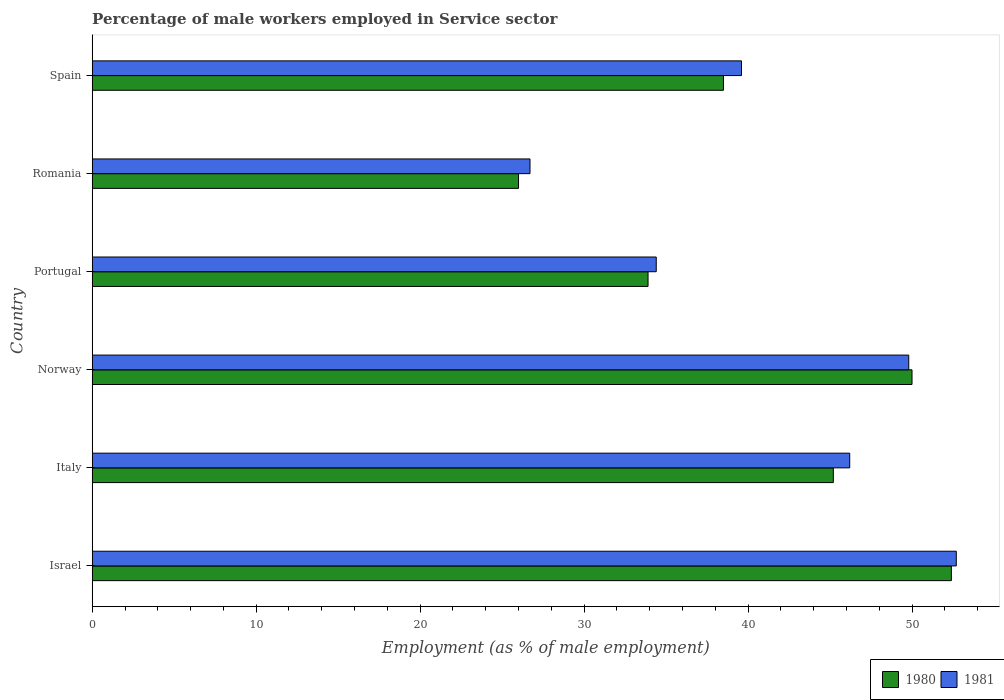How many different coloured bars are there?
Your answer should be very brief. 2. How many groups of bars are there?
Keep it short and to the point. 6. How many bars are there on the 4th tick from the bottom?
Make the answer very short. 2. In how many cases, is the number of bars for a given country not equal to the number of legend labels?
Ensure brevity in your answer.  0. What is the percentage of male workers employed in Service sector in 1980 in Norway?
Your answer should be very brief. 50. Across all countries, what is the maximum percentage of male workers employed in Service sector in 1980?
Provide a short and direct response. 52.4. In which country was the percentage of male workers employed in Service sector in 1980 minimum?
Your answer should be very brief. Romania. What is the total percentage of male workers employed in Service sector in 1981 in the graph?
Offer a terse response. 249.4. What is the difference between the percentage of male workers employed in Service sector in 1980 in Italy and the percentage of male workers employed in Service sector in 1981 in Norway?
Ensure brevity in your answer.  -4.6. What is the average percentage of male workers employed in Service sector in 1980 per country?
Offer a terse response. 41. What is the difference between the percentage of male workers employed in Service sector in 1981 and percentage of male workers employed in Service sector in 1980 in Italy?
Your response must be concise. 1. What is the ratio of the percentage of male workers employed in Service sector in 1981 in Israel to that in Norway?
Provide a short and direct response. 1.06. Is the difference between the percentage of male workers employed in Service sector in 1981 in Italy and Spain greater than the difference between the percentage of male workers employed in Service sector in 1980 in Italy and Spain?
Offer a very short reply. No. What is the difference between the highest and the second highest percentage of male workers employed in Service sector in 1981?
Your answer should be compact. 2.9. What is the difference between the highest and the lowest percentage of male workers employed in Service sector in 1980?
Make the answer very short. 26.4. In how many countries, is the percentage of male workers employed in Service sector in 1981 greater than the average percentage of male workers employed in Service sector in 1981 taken over all countries?
Provide a short and direct response. 3. What does the 2nd bar from the top in Spain represents?
Your answer should be compact. 1980. What does the 2nd bar from the bottom in Spain represents?
Your answer should be very brief. 1981. How many bars are there?
Ensure brevity in your answer.  12. What is the difference between two consecutive major ticks on the X-axis?
Provide a short and direct response. 10. Does the graph contain grids?
Make the answer very short. No. Where does the legend appear in the graph?
Give a very brief answer. Bottom right. How many legend labels are there?
Your answer should be very brief. 2. What is the title of the graph?
Your answer should be compact. Percentage of male workers employed in Service sector. What is the label or title of the X-axis?
Your response must be concise. Employment (as % of male employment). What is the label or title of the Y-axis?
Keep it short and to the point. Country. What is the Employment (as % of male employment) of 1980 in Israel?
Your response must be concise. 52.4. What is the Employment (as % of male employment) of 1981 in Israel?
Provide a short and direct response. 52.7. What is the Employment (as % of male employment) of 1980 in Italy?
Offer a terse response. 45.2. What is the Employment (as % of male employment) of 1981 in Italy?
Your answer should be compact. 46.2. What is the Employment (as % of male employment) in 1980 in Norway?
Your answer should be very brief. 50. What is the Employment (as % of male employment) of 1981 in Norway?
Give a very brief answer. 49.8. What is the Employment (as % of male employment) of 1980 in Portugal?
Your answer should be very brief. 33.9. What is the Employment (as % of male employment) in 1981 in Portugal?
Provide a short and direct response. 34.4. What is the Employment (as % of male employment) in 1980 in Romania?
Give a very brief answer. 26. What is the Employment (as % of male employment) of 1981 in Romania?
Provide a succinct answer. 26.7. What is the Employment (as % of male employment) in 1980 in Spain?
Your answer should be compact. 38.5. What is the Employment (as % of male employment) of 1981 in Spain?
Provide a short and direct response. 39.6. Across all countries, what is the maximum Employment (as % of male employment) of 1980?
Offer a terse response. 52.4. Across all countries, what is the maximum Employment (as % of male employment) in 1981?
Give a very brief answer. 52.7. Across all countries, what is the minimum Employment (as % of male employment) of 1981?
Offer a very short reply. 26.7. What is the total Employment (as % of male employment) of 1980 in the graph?
Your response must be concise. 246. What is the total Employment (as % of male employment) in 1981 in the graph?
Offer a very short reply. 249.4. What is the difference between the Employment (as % of male employment) in 1980 in Israel and that in Italy?
Offer a terse response. 7.2. What is the difference between the Employment (as % of male employment) of 1981 in Israel and that in Italy?
Offer a terse response. 6.5. What is the difference between the Employment (as % of male employment) in 1980 in Israel and that in Norway?
Provide a short and direct response. 2.4. What is the difference between the Employment (as % of male employment) of 1980 in Israel and that in Portugal?
Offer a terse response. 18.5. What is the difference between the Employment (as % of male employment) in 1980 in Israel and that in Romania?
Make the answer very short. 26.4. What is the difference between the Employment (as % of male employment) in 1980 in Israel and that in Spain?
Give a very brief answer. 13.9. What is the difference between the Employment (as % of male employment) in 1980 in Italy and that in Portugal?
Your answer should be compact. 11.3. What is the difference between the Employment (as % of male employment) in 1981 in Italy and that in Portugal?
Provide a succinct answer. 11.8. What is the difference between the Employment (as % of male employment) in 1981 in Italy and that in Romania?
Offer a terse response. 19.5. What is the difference between the Employment (as % of male employment) of 1980 in Italy and that in Spain?
Provide a short and direct response. 6.7. What is the difference between the Employment (as % of male employment) in 1981 in Norway and that in Portugal?
Offer a very short reply. 15.4. What is the difference between the Employment (as % of male employment) of 1980 in Norway and that in Romania?
Make the answer very short. 24. What is the difference between the Employment (as % of male employment) of 1981 in Norway and that in Romania?
Ensure brevity in your answer.  23.1. What is the difference between the Employment (as % of male employment) of 1981 in Norway and that in Spain?
Offer a very short reply. 10.2. What is the difference between the Employment (as % of male employment) of 1980 in Portugal and that in Romania?
Your answer should be very brief. 7.9. What is the difference between the Employment (as % of male employment) of 1980 in Portugal and that in Spain?
Your answer should be compact. -4.6. What is the difference between the Employment (as % of male employment) in 1980 in Israel and the Employment (as % of male employment) in 1981 in Norway?
Offer a terse response. 2.6. What is the difference between the Employment (as % of male employment) of 1980 in Israel and the Employment (as % of male employment) of 1981 in Portugal?
Ensure brevity in your answer.  18. What is the difference between the Employment (as % of male employment) of 1980 in Israel and the Employment (as % of male employment) of 1981 in Romania?
Make the answer very short. 25.7. What is the difference between the Employment (as % of male employment) of 1980 in Israel and the Employment (as % of male employment) of 1981 in Spain?
Your answer should be very brief. 12.8. What is the difference between the Employment (as % of male employment) in 1980 in Italy and the Employment (as % of male employment) in 1981 in Portugal?
Offer a very short reply. 10.8. What is the difference between the Employment (as % of male employment) in 1980 in Italy and the Employment (as % of male employment) in 1981 in Romania?
Keep it short and to the point. 18.5. What is the difference between the Employment (as % of male employment) in 1980 in Italy and the Employment (as % of male employment) in 1981 in Spain?
Make the answer very short. 5.6. What is the difference between the Employment (as % of male employment) of 1980 in Norway and the Employment (as % of male employment) of 1981 in Romania?
Give a very brief answer. 23.3. What is the average Employment (as % of male employment) of 1980 per country?
Keep it short and to the point. 41. What is the average Employment (as % of male employment) in 1981 per country?
Your answer should be very brief. 41.57. What is the difference between the Employment (as % of male employment) in 1980 and Employment (as % of male employment) in 1981 in Italy?
Your answer should be very brief. -1. What is the difference between the Employment (as % of male employment) in 1980 and Employment (as % of male employment) in 1981 in Portugal?
Your response must be concise. -0.5. What is the difference between the Employment (as % of male employment) in 1980 and Employment (as % of male employment) in 1981 in Romania?
Offer a very short reply. -0.7. What is the ratio of the Employment (as % of male employment) in 1980 in Israel to that in Italy?
Offer a very short reply. 1.16. What is the ratio of the Employment (as % of male employment) of 1981 in Israel to that in Italy?
Your answer should be very brief. 1.14. What is the ratio of the Employment (as % of male employment) in 1980 in Israel to that in Norway?
Your answer should be compact. 1.05. What is the ratio of the Employment (as % of male employment) of 1981 in Israel to that in Norway?
Provide a short and direct response. 1.06. What is the ratio of the Employment (as % of male employment) of 1980 in Israel to that in Portugal?
Make the answer very short. 1.55. What is the ratio of the Employment (as % of male employment) in 1981 in Israel to that in Portugal?
Ensure brevity in your answer.  1.53. What is the ratio of the Employment (as % of male employment) in 1980 in Israel to that in Romania?
Your answer should be very brief. 2.02. What is the ratio of the Employment (as % of male employment) in 1981 in Israel to that in Romania?
Offer a terse response. 1.97. What is the ratio of the Employment (as % of male employment) of 1980 in Israel to that in Spain?
Provide a short and direct response. 1.36. What is the ratio of the Employment (as % of male employment) of 1981 in Israel to that in Spain?
Provide a succinct answer. 1.33. What is the ratio of the Employment (as % of male employment) of 1980 in Italy to that in Norway?
Offer a terse response. 0.9. What is the ratio of the Employment (as % of male employment) of 1981 in Italy to that in Norway?
Make the answer very short. 0.93. What is the ratio of the Employment (as % of male employment) in 1980 in Italy to that in Portugal?
Give a very brief answer. 1.33. What is the ratio of the Employment (as % of male employment) of 1981 in Italy to that in Portugal?
Your response must be concise. 1.34. What is the ratio of the Employment (as % of male employment) in 1980 in Italy to that in Romania?
Make the answer very short. 1.74. What is the ratio of the Employment (as % of male employment) in 1981 in Italy to that in Romania?
Provide a succinct answer. 1.73. What is the ratio of the Employment (as % of male employment) in 1980 in Italy to that in Spain?
Ensure brevity in your answer.  1.17. What is the ratio of the Employment (as % of male employment) of 1980 in Norway to that in Portugal?
Keep it short and to the point. 1.47. What is the ratio of the Employment (as % of male employment) in 1981 in Norway to that in Portugal?
Offer a very short reply. 1.45. What is the ratio of the Employment (as % of male employment) of 1980 in Norway to that in Romania?
Give a very brief answer. 1.92. What is the ratio of the Employment (as % of male employment) in 1981 in Norway to that in Romania?
Make the answer very short. 1.87. What is the ratio of the Employment (as % of male employment) in 1980 in Norway to that in Spain?
Provide a succinct answer. 1.3. What is the ratio of the Employment (as % of male employment) in 1981 in Norway to that in Spain?
Provide a succinct answer. 1.26. What is the ratio of the Employment (as % of male employment) in 1980 in Portugal to that in Romania?
Give a very brief answer. 1.3. What is the ratio of the Employment (as % of male employment) of 1981 in Portugal to that in Romania?
Offer a terse response. 1.29. What is the ratio of the Employment (as % of male employment) of 1980 in Portugal to that in Spain?
Offer a terse response. 0.88. What is the ratio of the Employment (as % of male employment) of 1981 in Portugal to that in Spain?
Make the answer very short. 0.87. What is the ratio of the Employment (as % of male employment) in 1980 in Romania to that in Spain?
Provide a short and direct response. 0.68. What is the ratio of the Employment (as % of male employment) in 1981 in Romania to that in Spain?
Make the answer very short. 0.67. What is the difference between the highest and the second highest Employment (as % of male employment) in 1980?
Keep it short and to the point. 2.4. What is the difference between the highest and the second highest Employment (as % of male employment) of 1981?
Your answer should be compact. 2.9. What is the difference between the highest and the lowest Employment (as % of male employment) in 1980?
Keep it short and to the point. 26.4. What is the difference between the highest and the lowest Employment (as % of male employment) of 1981?
Your answer should be compact. 26. 